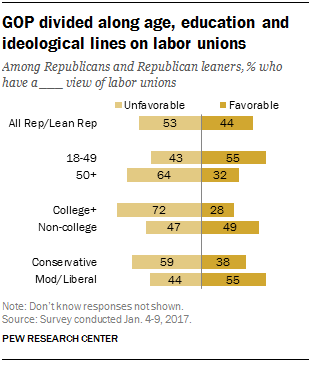Indicate a few pertinent items in this graphic. The total sum of college+ for unfavorable and favorable is 100. The smallest value in the bars is 28. 